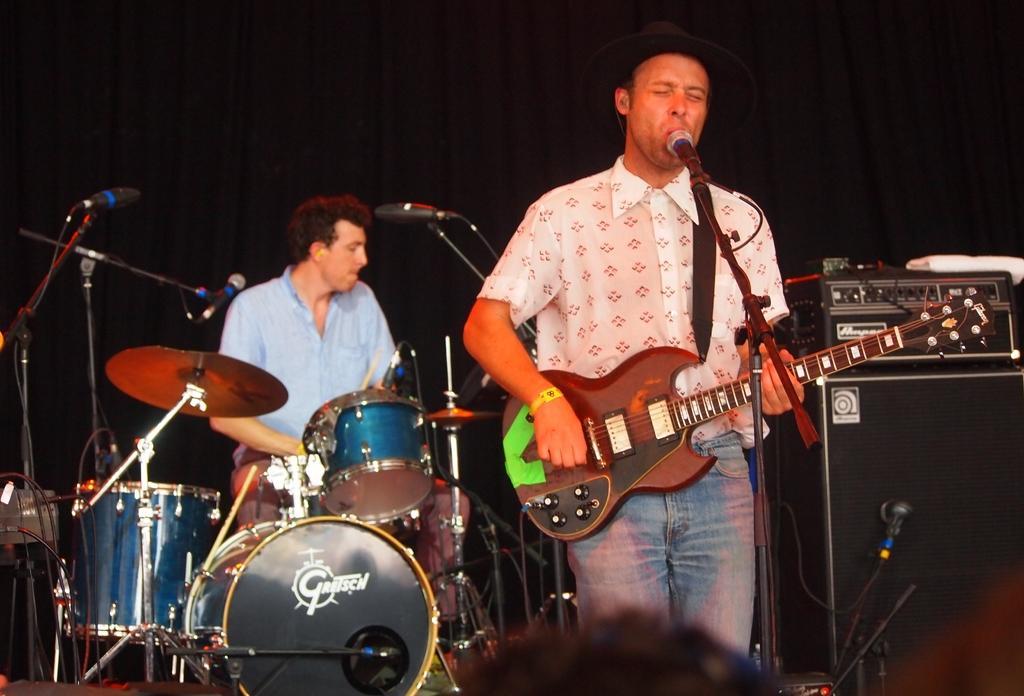Could you give a brief overview of what you see in this image? People playing musical instruments. 